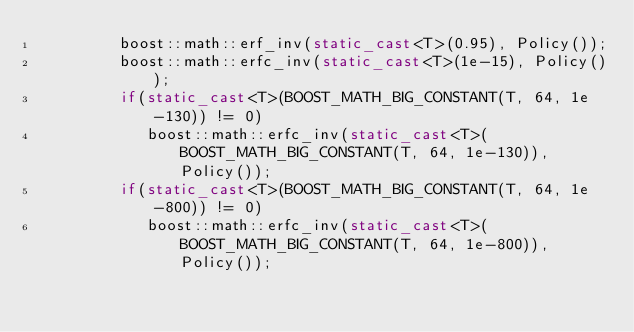<code> <loc_0><loc_0><loc_500><loc_500><_C++_>         boost::math::erf_inv(static_cast<T>(0.95), Policy());
         boost::math::erfc_inv(static_cast<T>(1e-15), Policy());
         if(static_cast<T>(BOOST_MATH_BIG_CONSTANT(T, 64, 1e-130)) != 0)
            boost::math::erfc_inv(static_cast<T>(BOOST_MATH_BIG_CONSTANT(T, 64, 1e-130)), Policy());
         if(static_cast<T>(BOOST_MATH_BIG_CONSTANT(T, 64, 1e-800)) != 0)
            boost::math::erfc_inv(static_cast<T>(BOOST_MATH_BIG_CONSTANT(T, 64, 1e-800)), Policy());</code> 